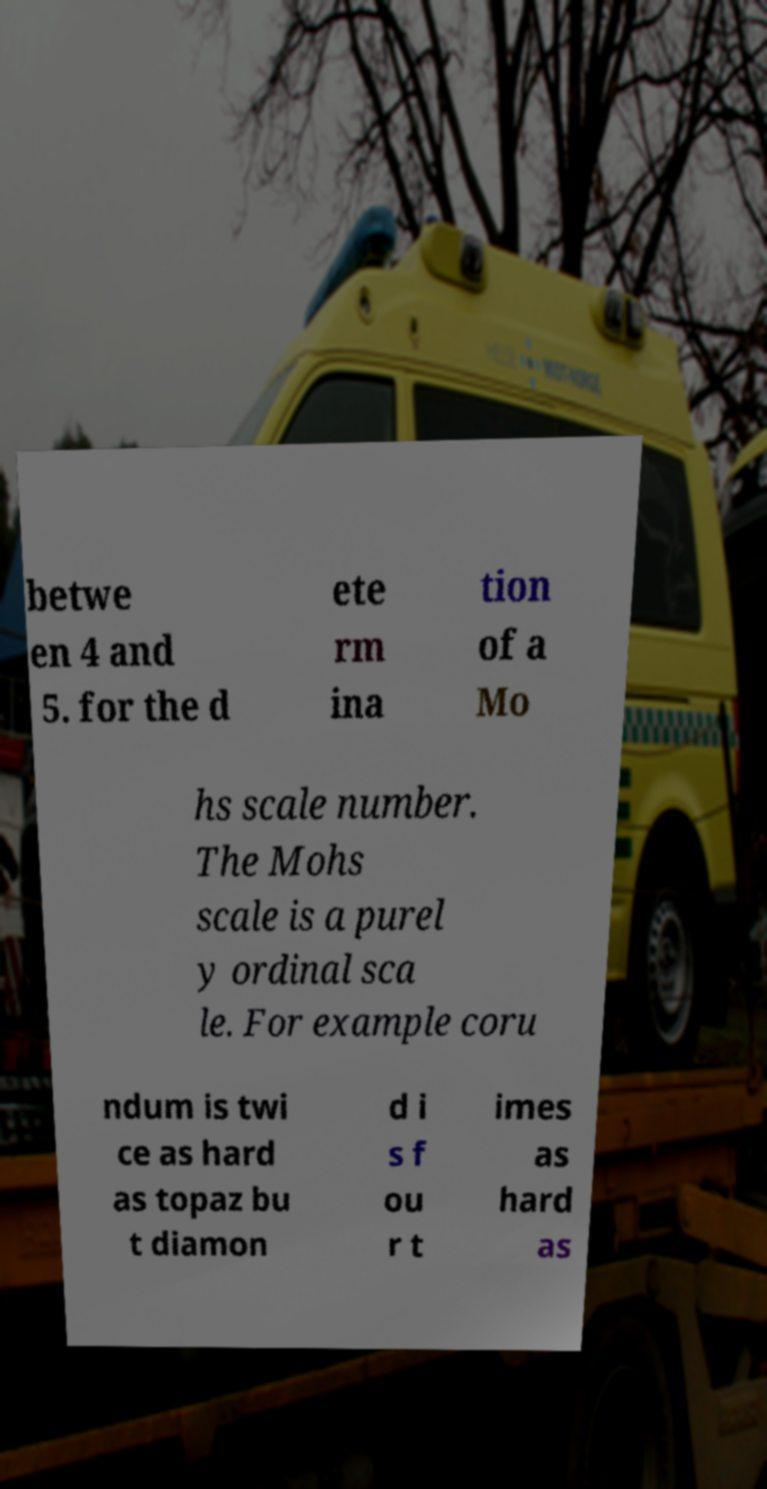Can you read and provide the text displayed in the image?This photo seems to have some interesting text. Can you extract and type it out for me? betwe en 4 and 5. for the d ete rm ina tion of a Mo hs scale number. The Mohs scale is a purel y ordinal sca le. For example coru ndum is twi ce as hard as topaz bu t diamon d i s f ou r t imes as hard as 